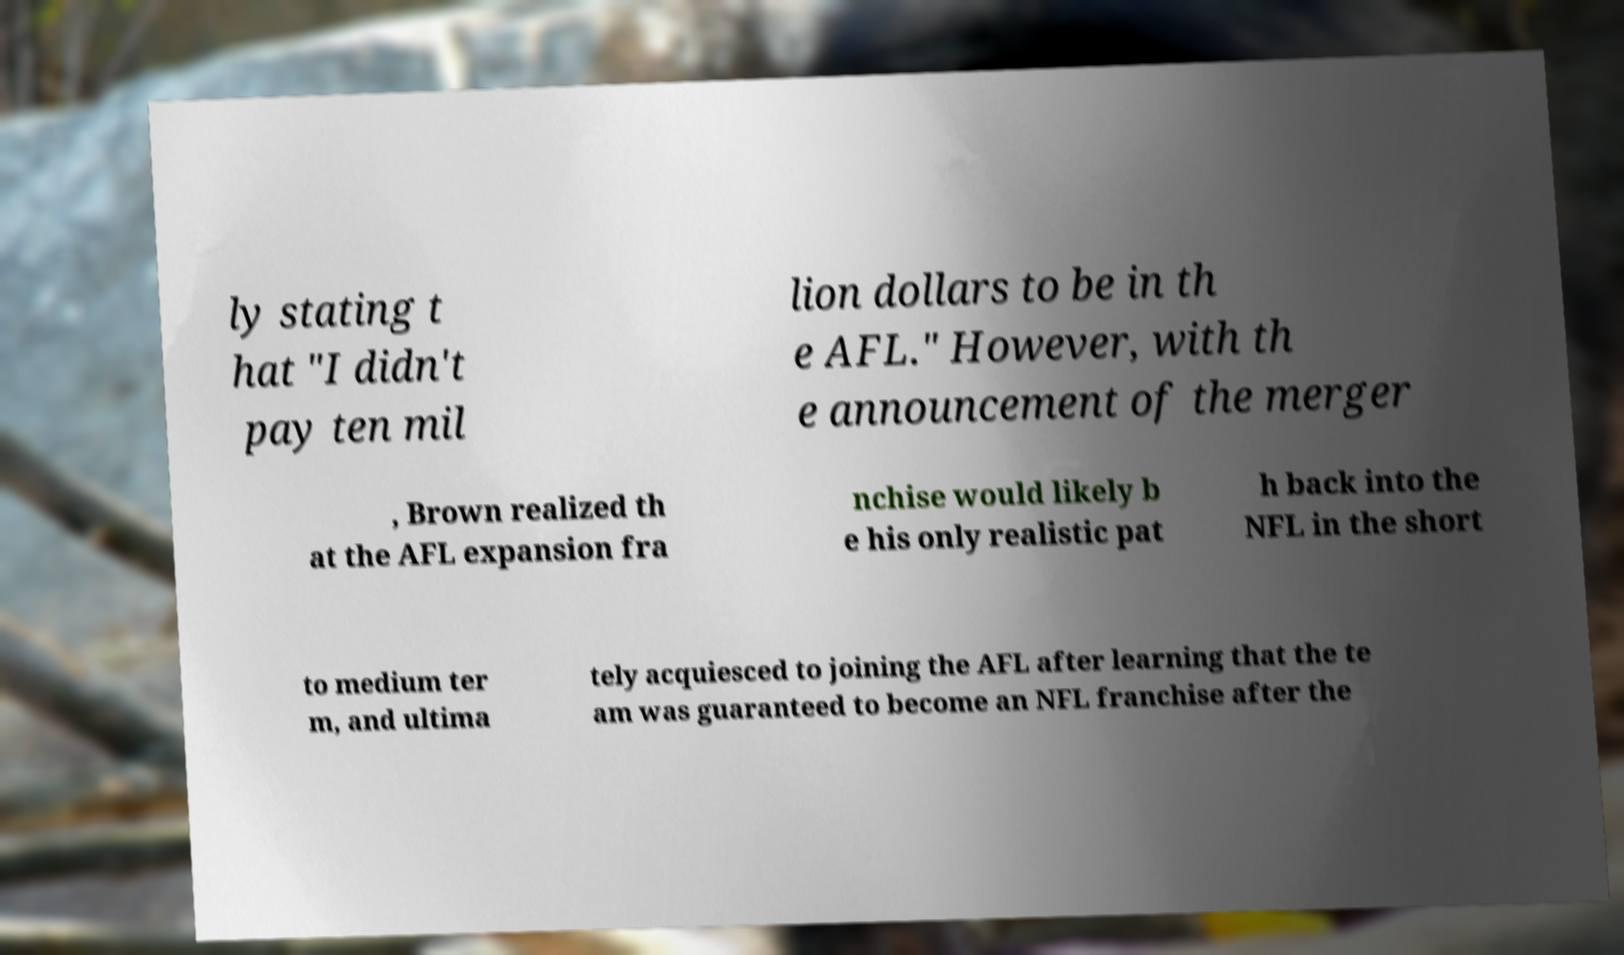Can you accurately transcribe the text from the provided image for me? ly stating t hat "I didn't pay ten mil lion dollars to be in th e AFL." However, with th e announcement of the merger , Brown realized th at the AFL expansion fra nchise would likely b e his only realistic pat h back into the NFL in the short to medium ter m, and ultima tely acquiesced to joining the AFL after learning that the te am was guaranteed to become an NFL franchise after the 